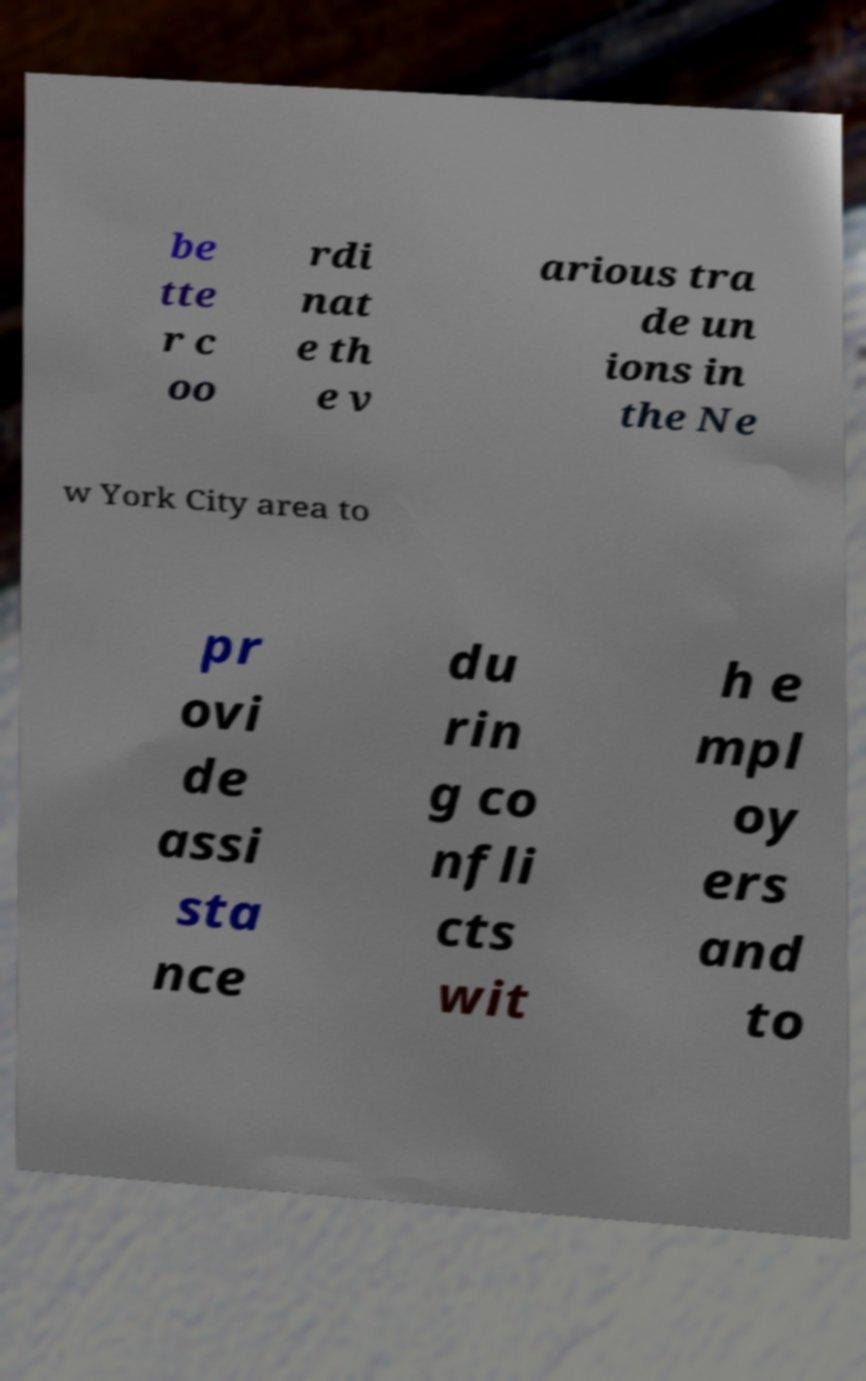Please read and relay the text visible in this image. What does it say? be tte r c oo rdi nat e th e v arious tra de un ions in the Ne w York City area to pr ovi de assi sta nce du rin g co nfli cts wit h e mpl oy ers and to 